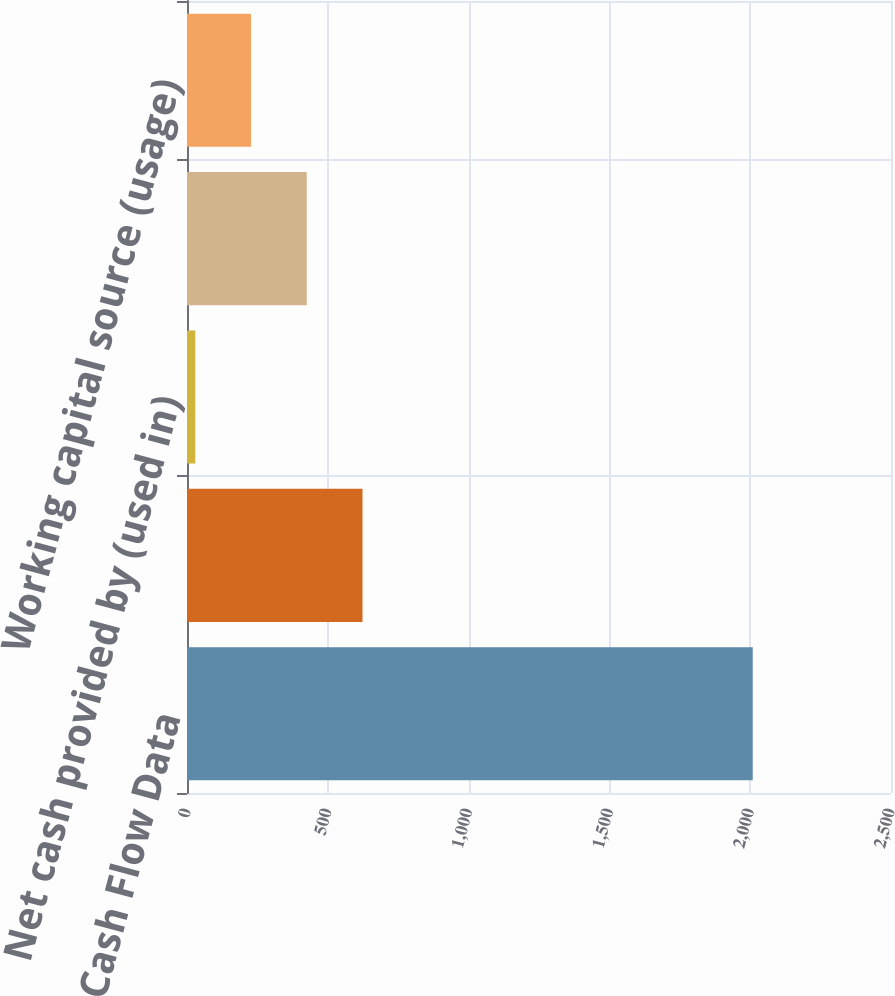Convert chart to OTSL. <chart><loc_0><loc_0><loc_500><loc_500><bar_chart><fcel>Cash Flow Data<fcel>Net cash provided by operating<fcel>Net cash provided by (used in)<fcel>Net cash used in financing<fcel>Working capital source (usage)<nl><fcel>2009<fcel>623.28<fcel>29.4<fcel>425.32<fcel>227.36<nl></chart> 